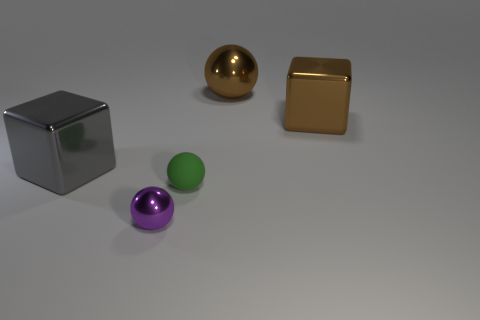Are there any small green objects to the right of the tiny rubber sphere?
Provide a short and direct response. No. How many objects are in front of the sphere to the left of the green matte sphere?
Offer a very short reply. 0. What is the material of the other sphere that is the same size as the green ball?
Offer a terse response. Metal. How many other things are made of the same material as the purple sphere?
Ensure brevity in your answer.  3. There is a tiny purple metal sphere; what number of tiny balls are behind it?
Offer a very short reply. 1. How many cubes are either brown shiny objects or tiny shiny objects?
Offer a very short reply. 1. There is a shiny thing that is left of the green ball and behind the small green sphere; how big is it?
Your answer should be very brief. Large. What number of other things are there of the same color as the tiny metal object?
Give a very brief answer. 0. Is the purple object made of the same material as the sphere behind the gray block?
Your answer should be very brief. Yes. What number of objects are either metallic objects that are in front of the rubber sphere or green rubber objects?
Give a very brief answer. 2. 